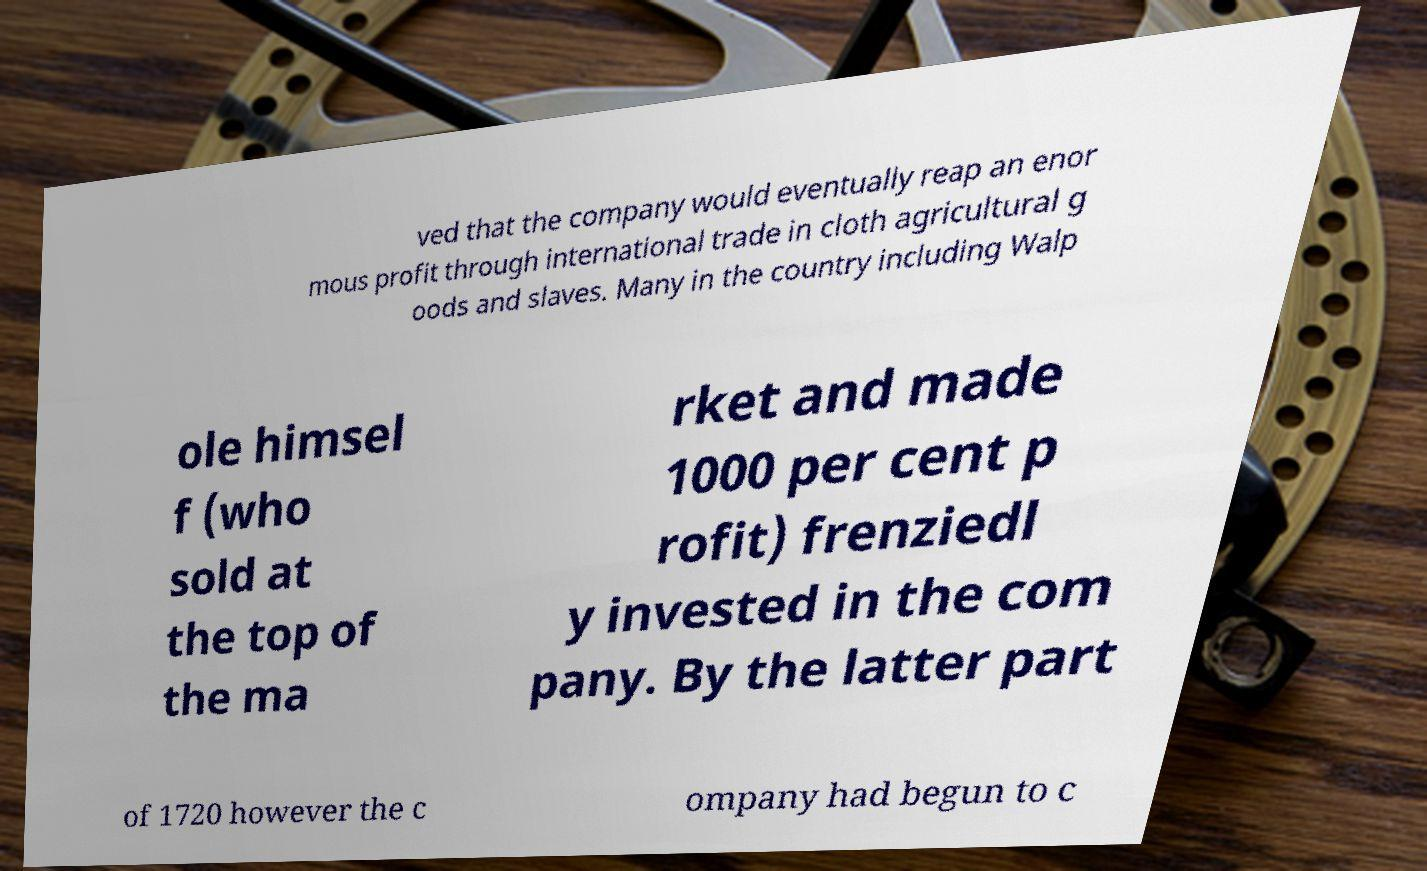Please read and relay the text visible in this image. What does it say? ved that the company would eventually reap an enor mous profit through international trade in cloth agricultural g oods and slaves. Many in the country including Walp ole himsel f (who sold at the top of the ma rket and made 1000 per cent p rofit) frenziedl y invested in the com pany. By the latter part of 1720 however the c ompany had begun to c 